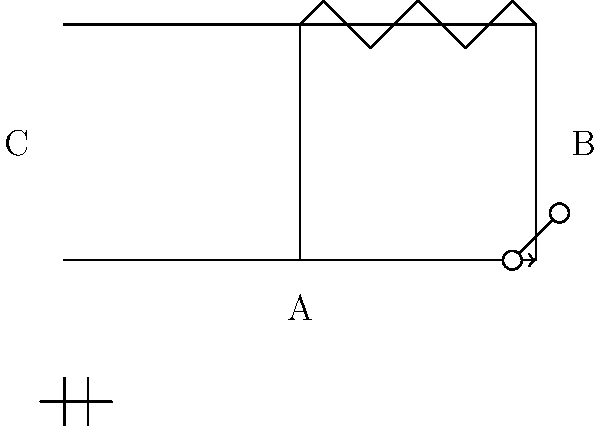In the simple electrical circuit diagram shown above, identify the components labeled A, B, and C. What do these symbols represent in a typical electrical schematic? To identify the components in this simple electrical circuit diagram, let's examine each labeled element:

1. Component A:
   This symbol represents a battery or voltage source. It consists of a longer line (positive terminal) and a shorter line (negative terminal) parallel to each other.

2. Component B:
   This symbol represents a switch. It's shown as two dots (connection points) with a line between them that can be opened or closed to control the flow of current.

3. Component C:
   This symbol represents a resistor. It's depicted as a zig-zag line, which is the standard symbol for a resistor in electrical schematics.

Additionally, the arrow in the circuit indicates the direction of conventional current flow, which is from the positive terminal of the battery to the negative terminal.

Understanding these basic symbols is crucial for reading and interpreting electrical circuit diagrams, even for those not specializing in electrical engineering. These components are fundamental building blocks in many electrical systems and can be found in various applications across different fields of study.
Answer: A: Battery, B: Switch, C: Resistor 